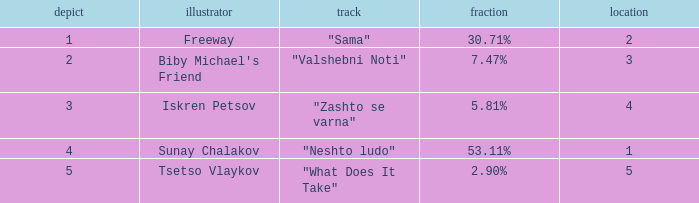What is the highest draw when the place is less than 3 and the percentage is 30.71%? 1.0. 